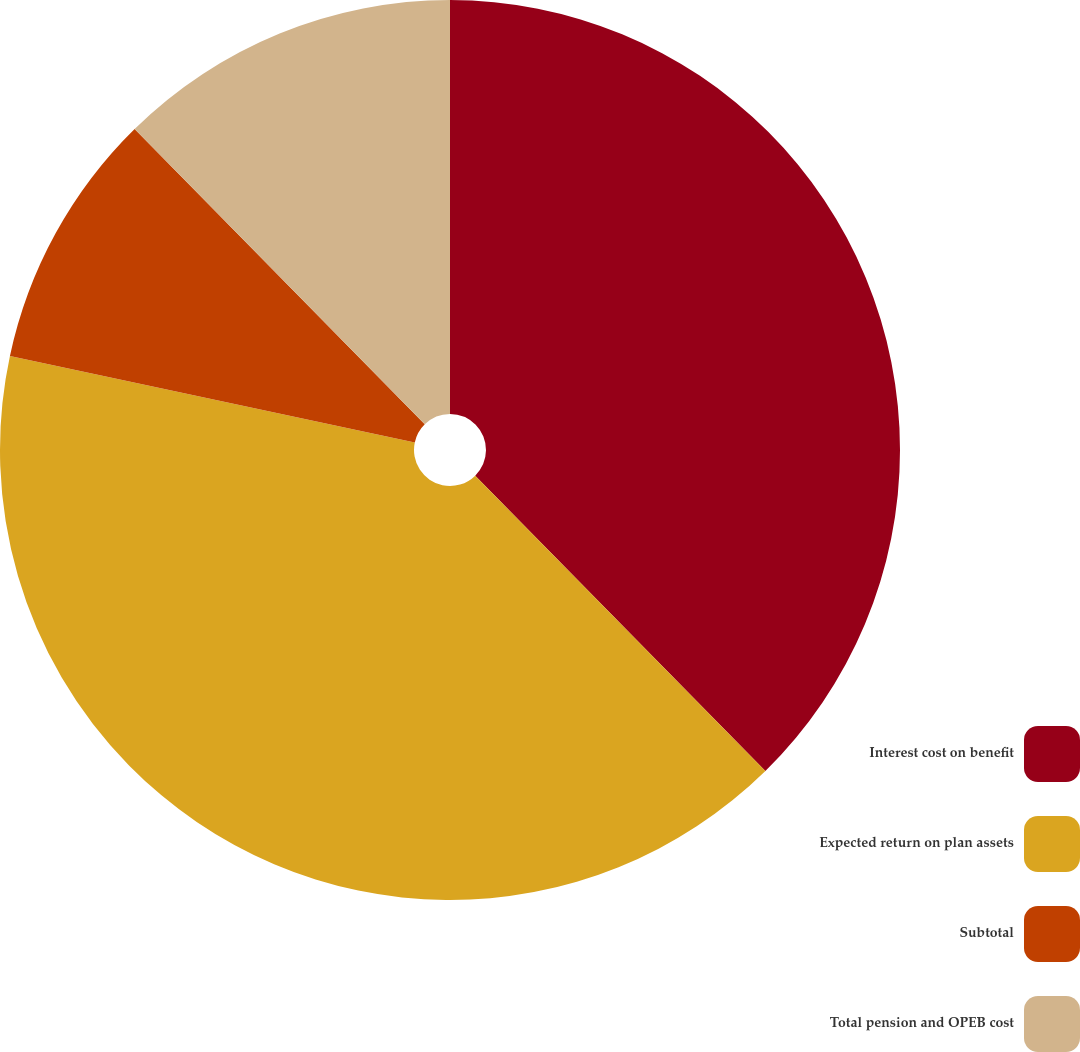Convert chart to OTSL. <chart><loc_0><loc_0><loc_500><loc_500><pie_chart><fcel>Interest cost on benefit<fcel>Expected return on plan assets<fcel>Subtotal<fcel>Total pension and OPEB cost<nl><fcel>37.64%<fcel>40.71%<fcel>9.29%<fcel>12.36%<nl></chart> 